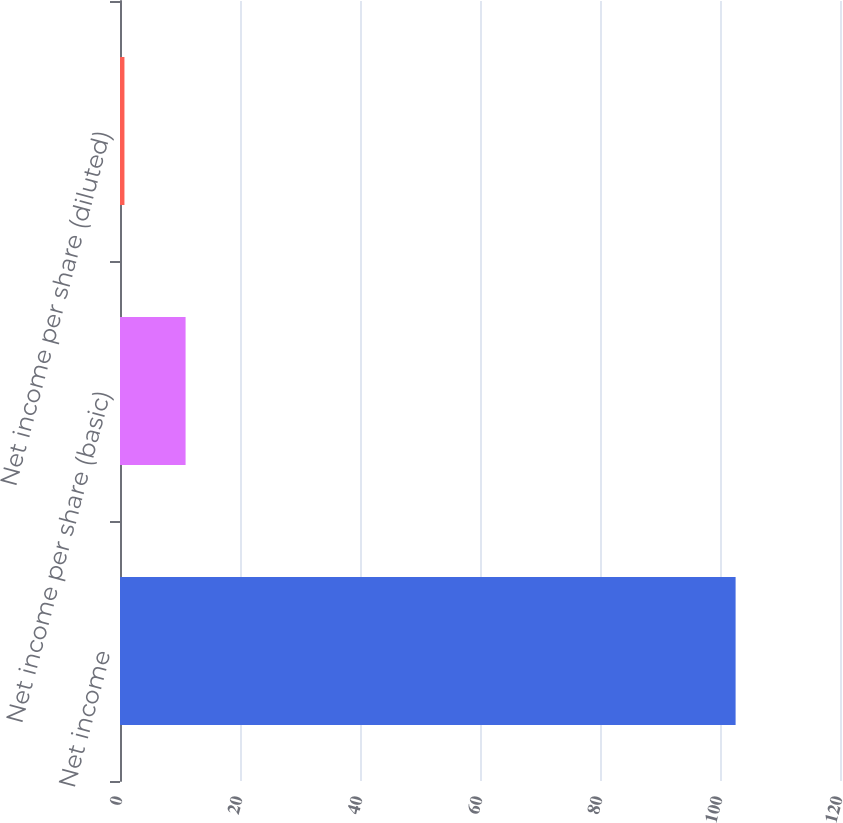Convert chart. <chart><loc_0><loc_0><loc_500><loc_500><bar_chart><fcel>Net income<fcel>Net income per share (basic)<fcel>Net income per share (diluted)<nl><fcel>102.6<fcel>10.93<fcel>0.74<nl></chart> 